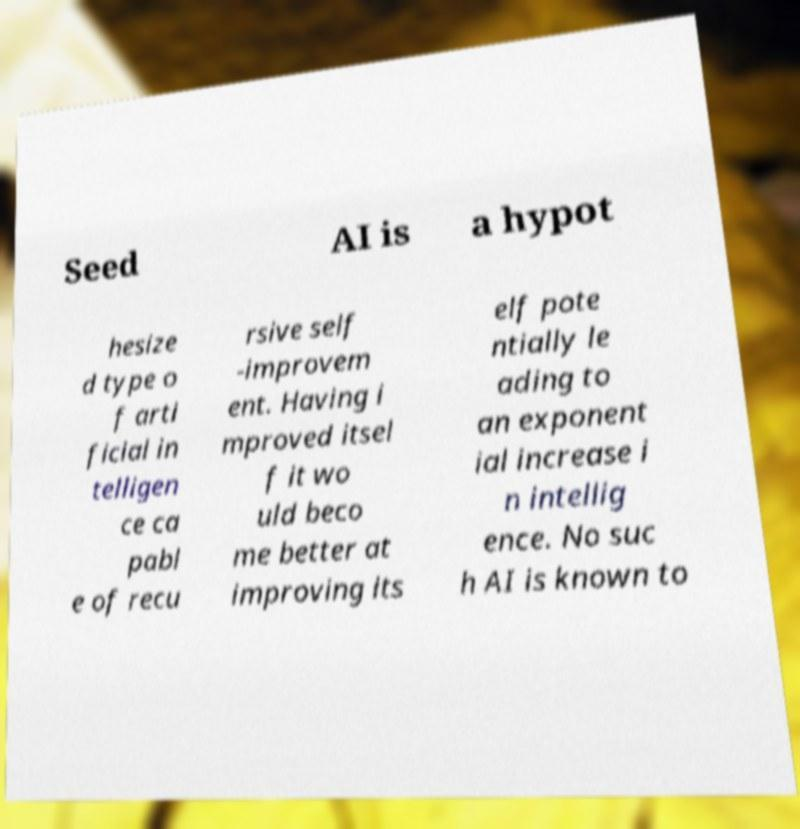Could you assist in decoding the text presented in this image and type it out clearly? Seed AI is a hypot hesize d type o f arti ficial in telligen ce ca pabl e of recu rsive self -improvem ent. Having i mproved itsel f it wo uld beco me better at improving its elf pote ntially le ading to an exponent ial increase i n intellig ence. No suc h AI is known to 